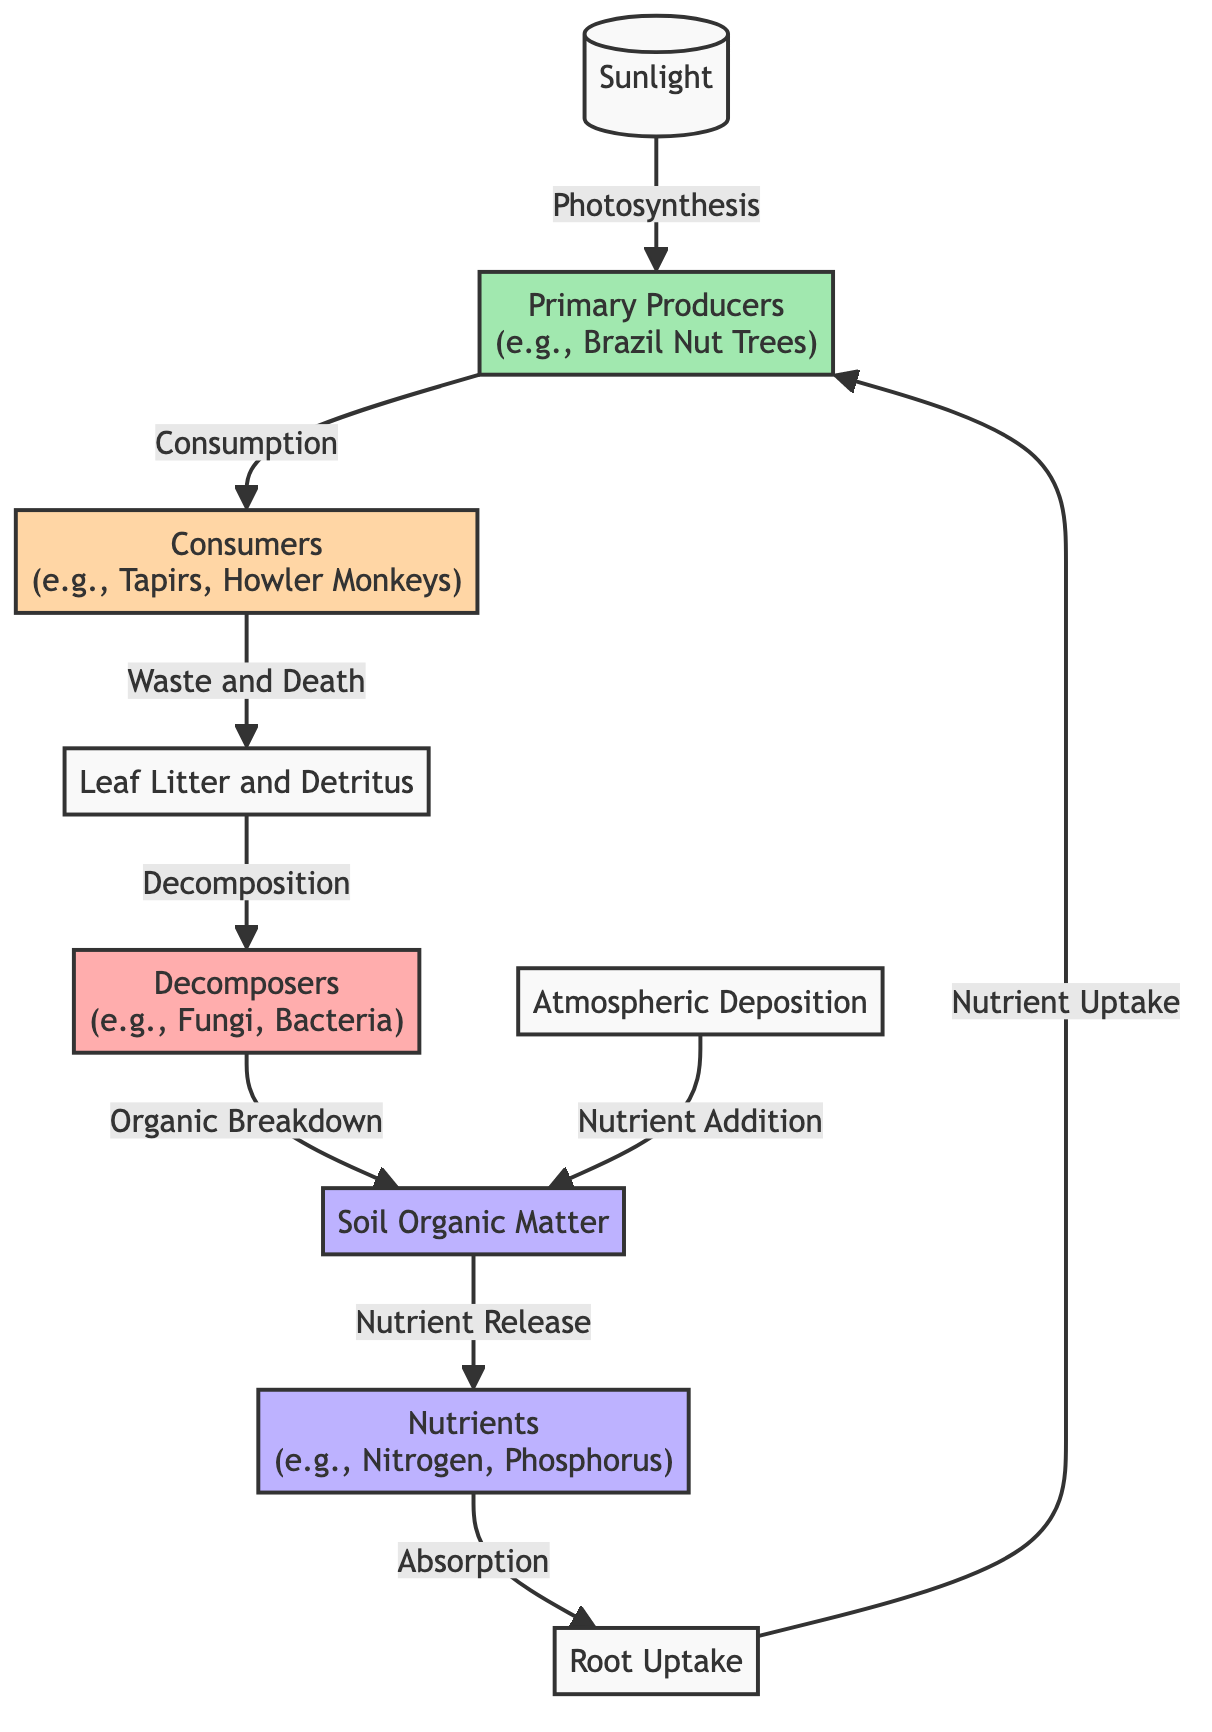What is the primary source of energy in the nutrient cycle? The diagram indicates that "Sunlight" is the primary energy source, as it is the starting point for photosynthesis, which fuels the entire cycle.
Answer: Sunlight Which organisms are considered primary producers in this cycle? The diagram highlights "Primary Producers" as having examples such as Brazil Nut Trees, which convert sunlight into chemical energy through photosynthesis.
Answer: Brazil Nut Trees How many types of consumers are shown in the diagram? There is one type of consumer indicated in the diagram, which is labeled under "Consumers" with examples like Tapirs and Howler Monkeys.
Answer: 1 What is the role of decomposers in this nutrient cycle? The diagram shows that decomposers, like fungi and bacteria, break down organic matter (from waste and death) releasing nutrients back into the soil organic matter, which is essential for nutrient cycling.
Answer: Organic Breakdown Which nutrients are released from soil organic matter? The diagram indicates that soil organic matter undergoes "Nutrient Release," specifically mentioning "Nitrogen" and "Phosphorus" as the key nutrients released into the soil.
Answer: Nitrogen, Phosphorus What process connects consumers back to primary producers? The diagram illustrates that after consumption by consumers, waste and death lead to the generation of leaf litter and detritus, which decomposes and feeds back into the cycle, eventually reaching root uptake of primary producers again.
Answer: Waste and Death How does atmospheric deposition contribute to the nutrient cycle? According to the diagram, atmospheric deposition adds nutrients directly to soil organic matter, which is an essential part of the nutrient cycle as it increases the nutrient availability for plants.
Answer: Nutrient Addition Which component directly absorbs nutrients in the cycle? The diagram specifies "Root Uptake" as the process through which nutrients released from soil are absorbed by primary producers, signifying a direct connection between nutrients in soil and plants.
Answer: Root Uptake What is the ultimate destination of nutrients in the cycle? The diagram portrays the flow of nutrients leading ultimately to the primary producers, showing that nutrients are absorbed back into the producers after their release from soil organic matter.
Answer: Primary Producers 